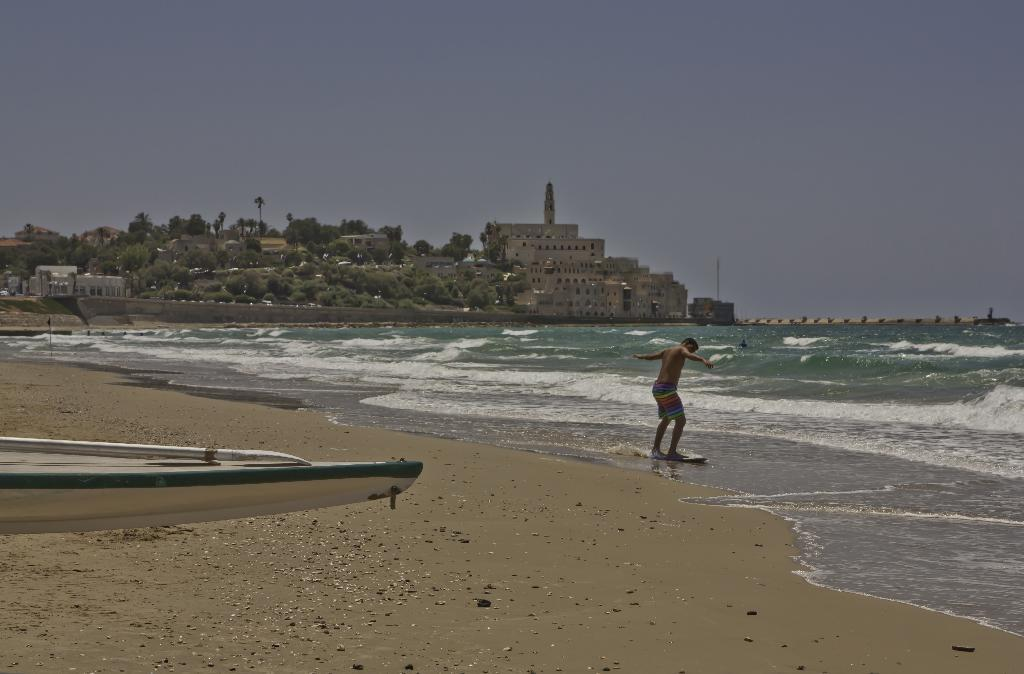What activity is the person in the image engaged in? The person is surfing in the image. Where is the person surfing? The person is surfing on the surface of a sea. What can be seen in the background of the image? There are buildings and trees visible in the background of the image. What type of terrain is visible at the bottom of the image? The bottom of the image shows a beach. What type of bat can be seen flying over the person surfing in the image? There is no bat present in the image; the person is surfing on the surface of a sea. What type of eggnog is being served at the downtown location visible in the image? There is no downtown location or eggnog present in the image; it shows a person surfing on the sea with buildings and trees in the background. 